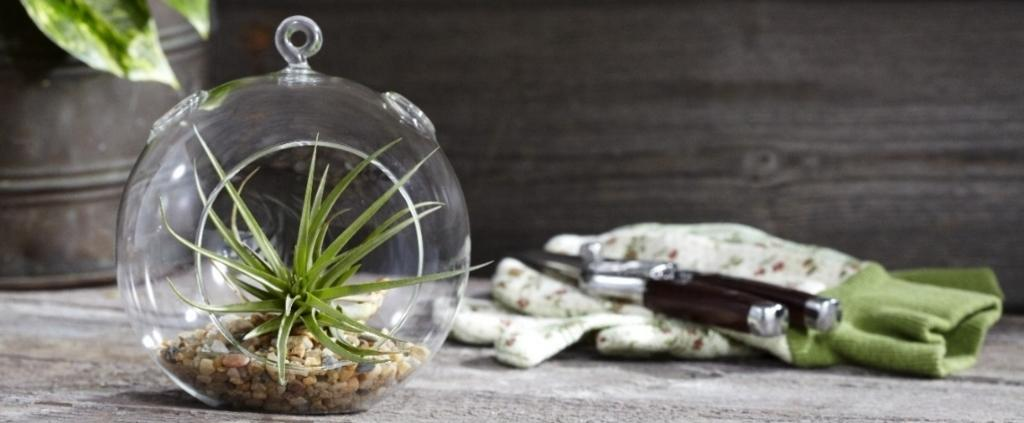What is located in the middle of the image? There are plants in the middle of the image. What is behind the plants in the image? There is a cloth behind the plants. Can you describe the object on the cloth? Unfortunately, the facts provided do not give enough information to describe the object on the cloth. What type of instrument can be seen playing in the background of the image? There is no instrument or music playing in the image; it features plants and a cloth. 